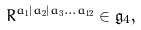Convert formula to latex. <formula><loc_0><loc_0><loc_500><loc_500>R ^ { a _ { 1 } | a _ { 2 } | a _ { 3 } \dots a _ { 1 2 } } \in \mathfrak { g } _ { 4 } ,</formula> 